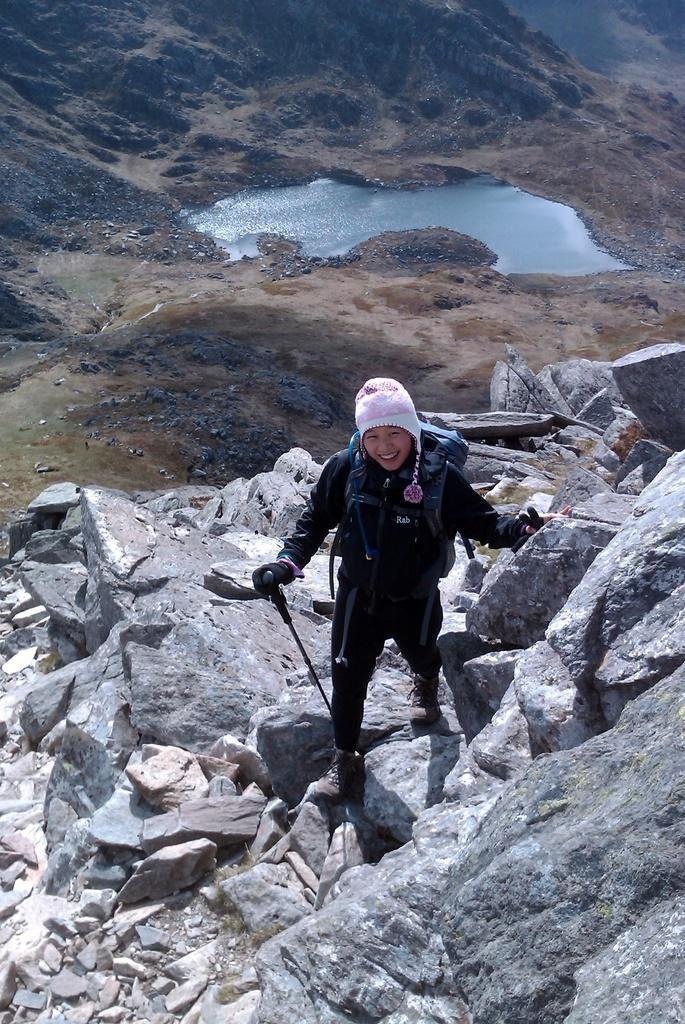Please provide a concise description of this image. In the picture I can see a woman standing on the rock and she is holding the skis in her right hand. She is carrying a bag and there is a smile on her face. In the background, I can see the water and hills. 